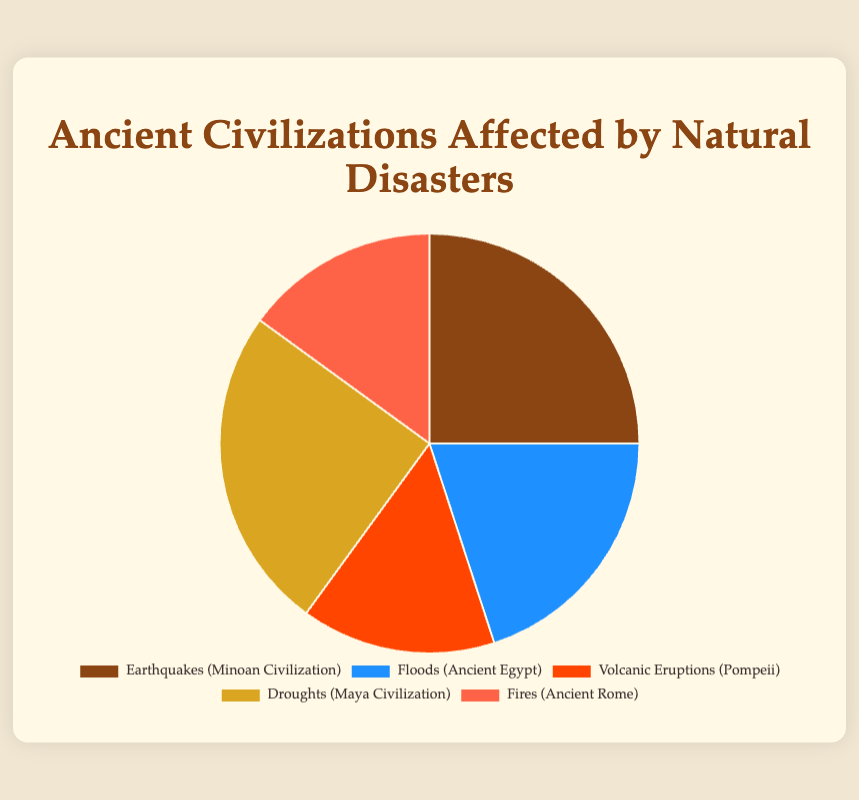Who are the two civilizations most affected by natural disasters? The pie chart shows percentages of ancient civilizations affected by natural disasters. The highest percentages are 25% for both Earthquakes (Minoan Civilization) and Droughts (Maya Civilization).
Answer: Minoan Civilization, Maya Civilization Which type of natural disaster affected the least number of ancient civilizations? The pie chart shows different percentages for each disaster type. The disasters with the lowest percentage, both with 15%, are Volcanic Eruptions (Pompeii) and Fires (Ancient Rome).
Answer: Volcanic Eruptions, Fires What is the combined percentage of civilizations affected by Floods and Fires? From the pie chart, the percentage of civilizations affected by Floods is 20% and by Fires is 15%. Adding these together gives 20 + 15 = 35.
Answer: 35% Which civilization affected by natural disasters shares the same percentage as the Pompeii civilization affected by Volcanic Eruptions? The pie chart indicates that Volcanic Eruptions (Pompeii) has a percentage of 15%. Referring to the chart, Fires (Ancient Rome) also has a percentage of 15%.
Answer: Ancient Rome How much higher is the percentage of civilizations affected by Earthquakes compared to Floods? According to the pie chart, the percentage for Earthquakes (Minoan Civilization) is 25%, and for Floods (Ancient Egypt), it is 20%. Subtracting these, 25 - 20 = 5.
Answer: 5% If the total percentage must equal 100%, what is the average percentage of the listed civilizations affected by natural disasters? Adding all the given percentages: 25 (Earthquakes) + 20 (Floods) + 15 (Volcanic Eruptions) + 25 (Droughts) + 15 (Fires) equals 100. There are 5 types of disasters, so the average is 100 / 5.
Answer: 20% Which natural disaster is shown in blue? By identifying the color coding in the pie chart, the disaster type associated with the color blue is Floods (Ancient Egypt).
Answer: Floods What is the percentage difference between the civilizations affected by Droughts and Fires? According to the pie chart, the percentage of civilizations affected by Droughts is 25%, and by Fires is 15%. The difference between them is 25 - 15 = 10.
Answer: 10% 